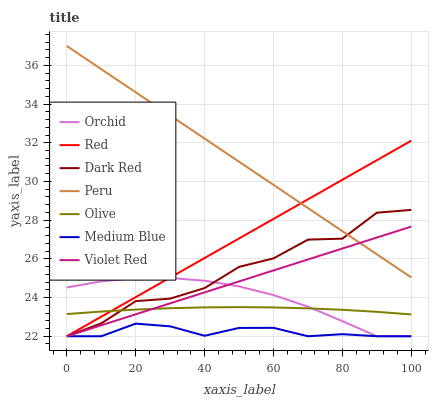Does Medium Blue have the minimum area under the curve?
Answer yes or no. Yes. Does Peru have the maximum area under the curve?
Answer yes or no. Yes. Does Dark Red have the minimum area under the curve?
Answer yes or no. No. Does Dark Red have the maximum area under the curve?
Answer yes or no. No. Is Peru the smoothest?
Answer yes or no. Yes. Is Dark Red the roughest?
Answer yes or no. Yes. Is Medium Blue the smoothest?
Answer yes or no. No. Is Medium Blue the roughest?
Answer yes or no. No. Does Violet Red have the lowest value?
Answer yes or no. Yes. Does Peru have the lowest value?
Answer yes or no. No. Does Peru have the highest value?
Answer yes or no. Yes. Does Dark Red have the highest value?
Answer yes or no. No. Is Olive less than Peru?
Answer yes or no. Yes. Is Olive greater than Medium Blue?
Answer yes or no. Yes. Does Olive intersect Red?
Answer yes or no. Yes. Is Olive less than Red?
Answer yes or no. No. Is Olive greater than Red?
Answer yes or no. No. Does Olive intersect Peru?
Answer yes or no. No. 